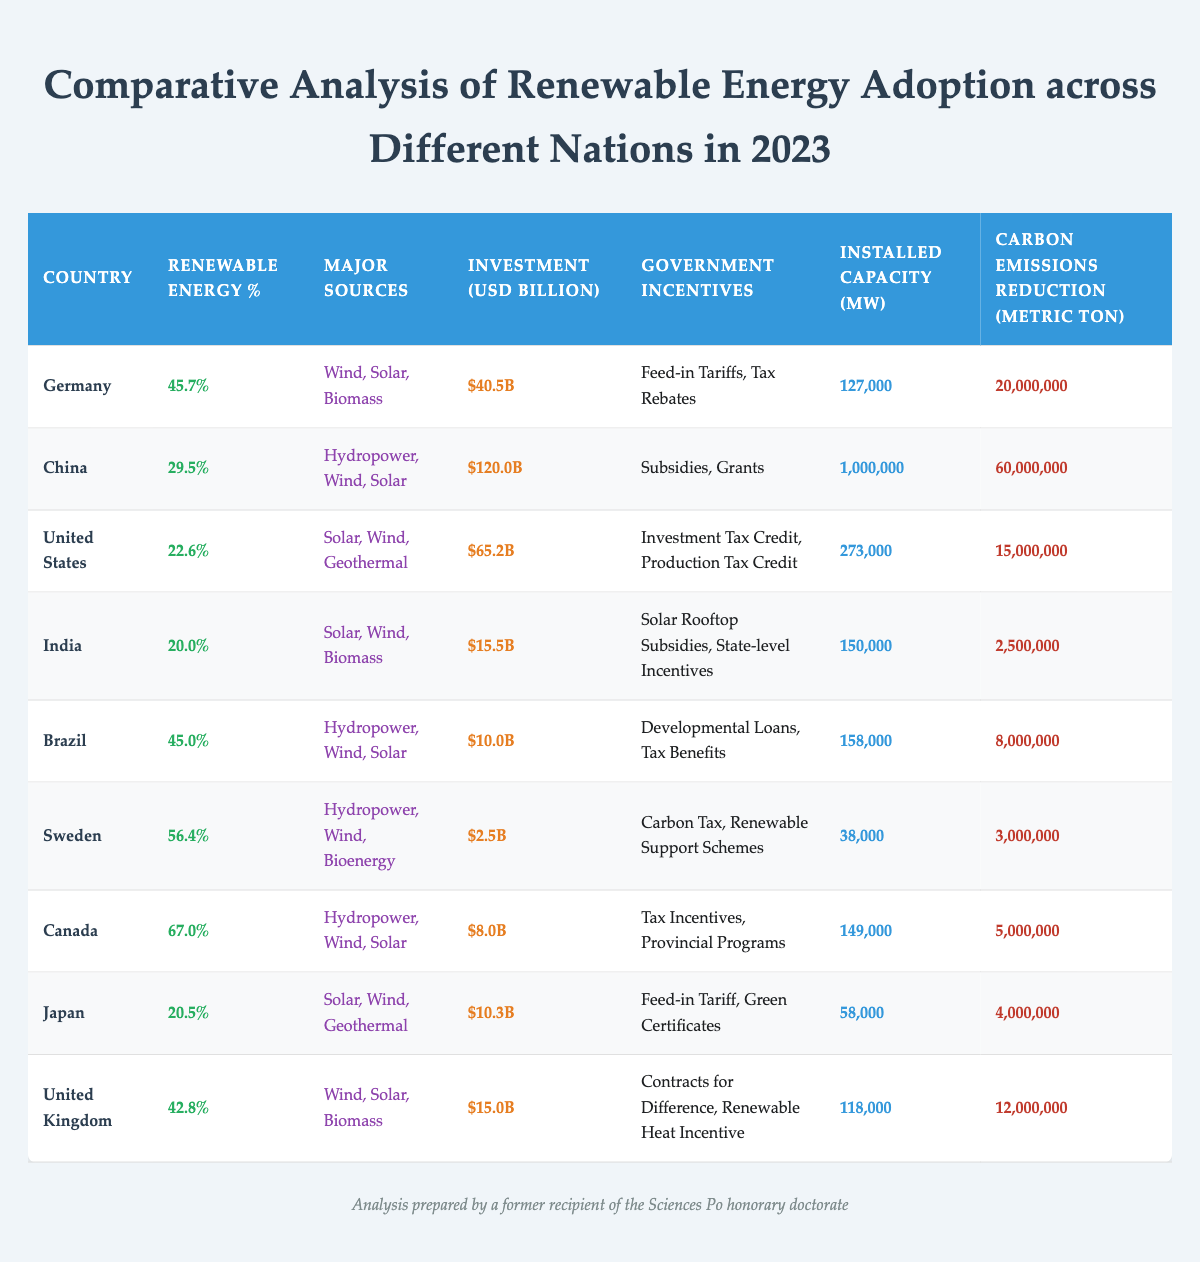What is the country with the highest percentage of renewable energy adoption? By looking at the Renewable Energy Percentage column, Canada shows the highest value at 67.0%.
Answer: Canada Which country has the lowest investment in renewable energy? The Investment in Renewables USD column shows that Sweden has the lowest investment at $2.5 billion.
Answer: Sweden How many metric tons of carbon emissions are reduced by Brazil's renewable energy efforts? From the Carbon Emissions Reduction Metric Ton column, Brazil has reduced carbon emissions by 8,000,000 metric tons.
Answer: 8,000,000 Which countries have a Renewable Energy Percentage above 40%? By examining the Renewable Energy Percentage column, the countries above 40% are Canada, Sweden, Germany, Brazil, and the United Kingdom.
Answer: Canada, Sweden, Germany, Brazil, United Kingdom What is the total installed capacity of renewable energy in Germany and the United Kingdom combined? The Installed Capacity MW for Germany is 127,000 and for the United Kingdom is 118,000. Adding these values gives 127,000 + 118,000 = 245,000 MW.
Answer: 245,000 MW Is India's investment in renewable energy higher than Japan's? The Investment in Renewables USD shows India at $15.5 billion and Japan at $10.3 billion. Since 15.5 is greater than 10.3, the statement is true.
Answer: Yes What is the average Renewable Energy Percentage for the countries listed? To find the average, sum the percentages (45.7 + 29.5 + 22.6 + 20.0 + 45.0 + 56.4 + 67.0 + 20.5 + 42.8) =  359.5%, and divide by the number of countries (9). This results in an average of 39.94%.
Answer: 39.94% Which country's major sources do not include hydropower? Observing the Major Sources column, India, Japan, and the United States do not have hydropower listed as a major source.
Answer: India, Japan, United States How many more metric tons of carbon emissions are reduced by China compared to India? China has a reduction of 60,000,000 metric tons and India has 2,500,000 metric tons. The difference is 60,000,000 - 2,500,000 = 57,500,000 metric tons.
Answer: 57,500,000 metric tons What incentives does Canada offer for renewable energy investment? By examining the Government Incentives column, Canada offers Tax Incentives and Provincial Programs.
Answer: Tax Incentives, Provincial Programs 